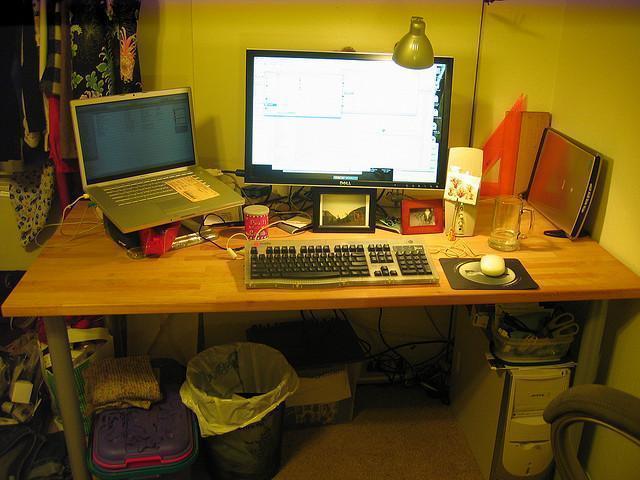What kind of cup is sat on the desk next to the computer mouse?
Pick the correct solution from the four options below to address the question.
Options: Glass, wine glass, tea cup, mug. Mug. 